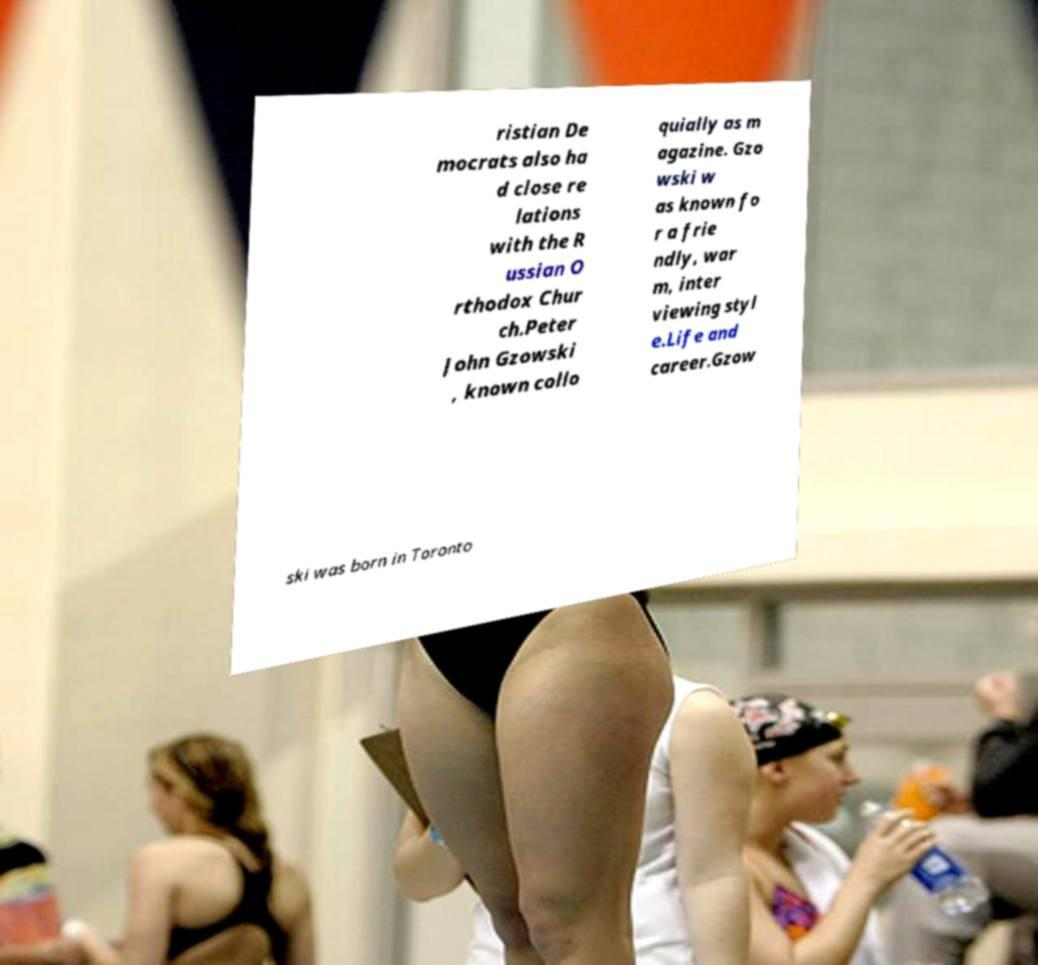Could you assist in decoding the text presented in this image and type it out clearly? ristian De mocrats also ha d close re lations with the R ussian O rthodox Chur ch.Peter John Gzowski , known collo quially as m agazine. Gzo wski w as known fo r a frie ndly, war m, inter viewing styl e.Life and career.Gzow ski was born in Toronto 